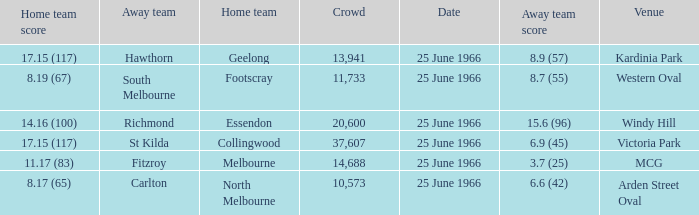What is the total crowd size when a home team scored 17.15 (117) versus hawthorn? 13941.0. 